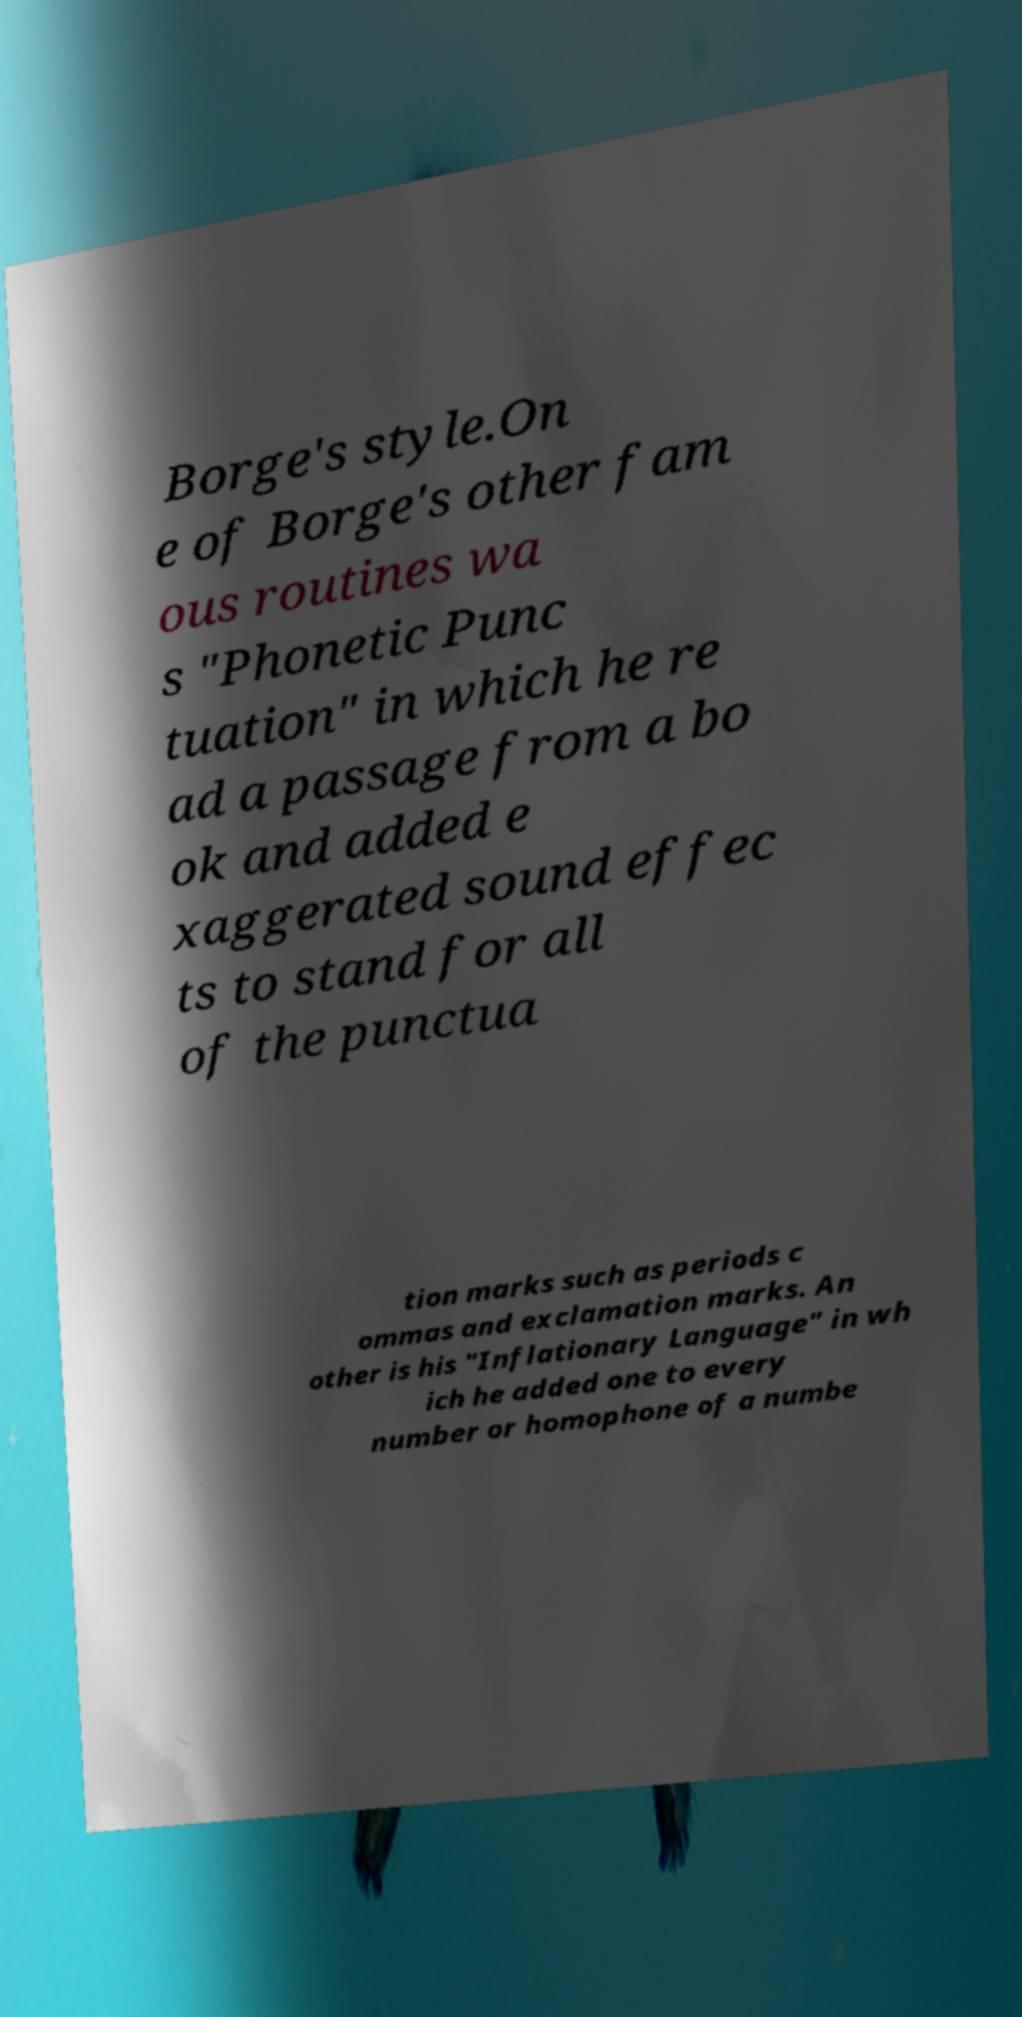There's text embedded in this image that I need extracted. Can you transcribe it verbatim? Borge's style.On e of Borge's other fam ous routines wa s "Phonetic Punc tuation" in which he re ad a passage from a bo ok and added e xaggerated sound effec ts to stand for all of the punctua tion marks such as periods c ommas and exclamation marks. An other is his "Inflationary Language" in wh ich he added one to every number or homophone of a numbe 